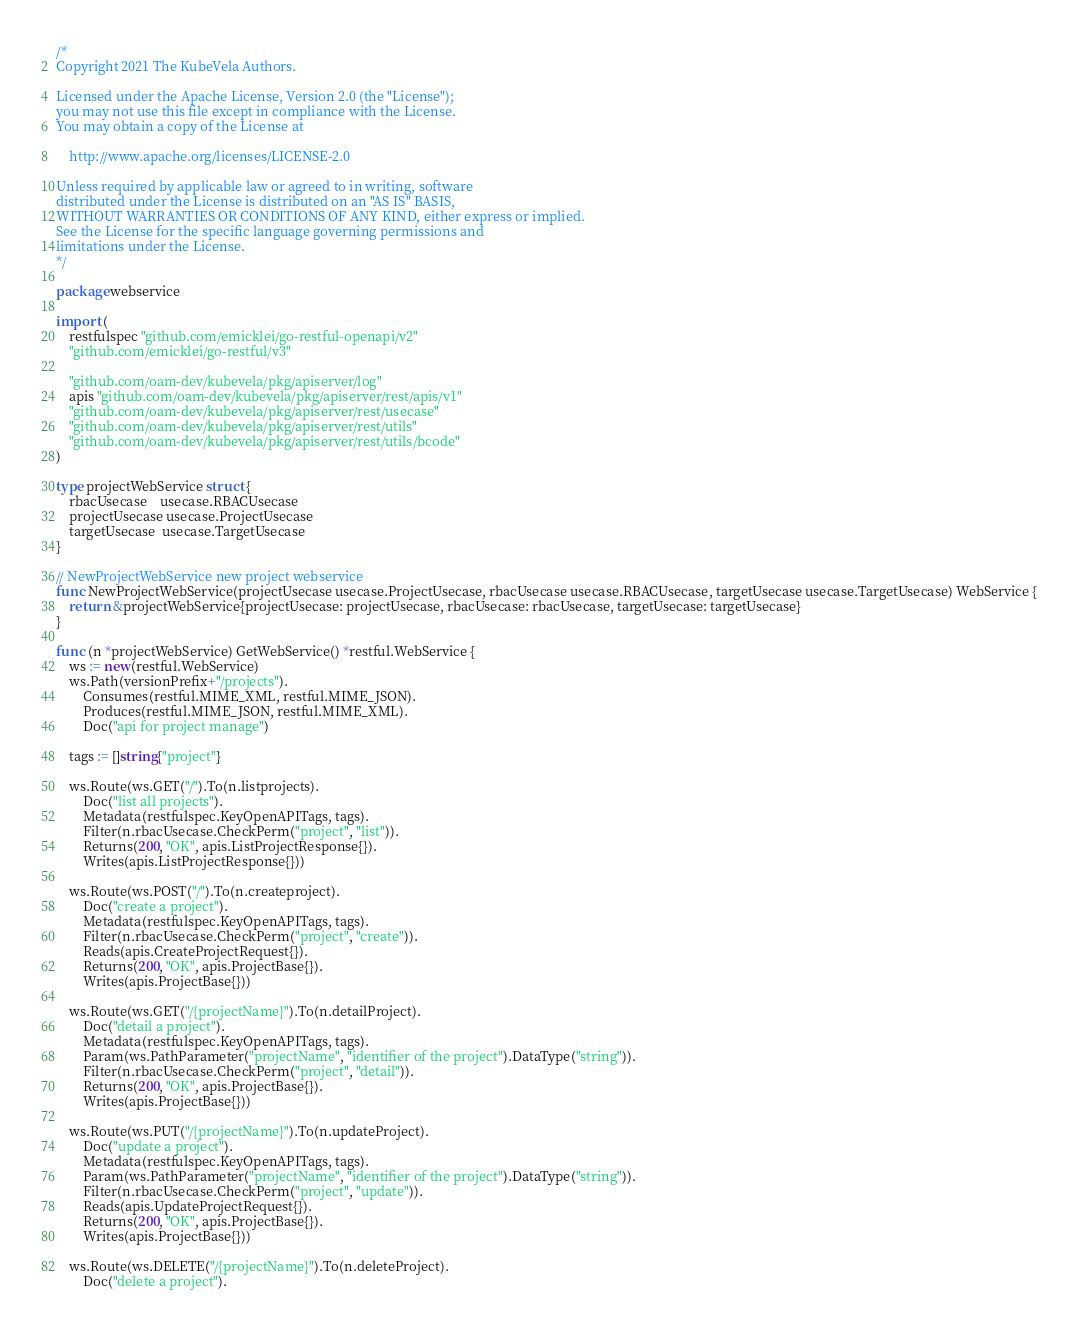<code> <loc_0><loc_0><loc_500><loc_500><_Go_>/*
Copyright 2021 The KubeVela Authors.

Licensed under the Apache License, Version 2.0 (the "License");
you may not use this file except in compliance with the License.
You may obtain a copy of the License at

	http://www.apache.org/licenses/LICENSE-2.0

Unless required by applicable law or agreed to in writing, software
distributed under the License is distributed on an "AS IS" BASIS,
WITHOUT WARRANTIES OR CONDITIONS OF ANY KIND, either express or implied.
See the License for the specific language governing permissions and
limitations under the License.
*/

package webservice

import (
	restfulspec "github.com/emicklei/go-restful-openapi/v2"
	"github.com/emicklei/go-restful/v3"

	"github.com/oam-dev/kubevela/pkg/apiserver/log"
	apis "github.com/oam-dev/kubevela/pkg/apiserver/rest/apis/v1"
	"github.com/oam-dev/kubevela/pkg/apiserver/rest/usecase"
	"github.com/oam-dev/kubevela/pkg/apiserver/rest/utils"
	"github.com/oam-dev/kubevela/pkg/apiserver/rest/utils/bcode"
)

type projectWebService struct {
	rbacUsecase    usecase.RBACUsecase
	projectUsecase usecase.ProjectUsecase
	targetUsecase  usecase.TargetUsecase
}

// NewProjectWebService new project webservice
func NewProjectWebService(projectUsecase usecase.ProjectUsecase, rbacUsecase usecase.RBACUsecase, targetUsecase usecase.TargetUsecase) WebService {
	return &projectWebService{projectUsecase: projectUsecase, rbacUsecase: rbacUsecase, targetUsecase: targetUsecase}
}

func (n *projectWebService) GetWebService() *restful.WebService {
	ws := new(restful.WebService)
	ws.Path(versionPrefix+"/projects").
		Consumes(restful.MIME_XML, restful.MIME_JSON).
		Produces(restful.MIME_JSON, restful.MIME_XML).
		Doc("api for project manage")

	tags := []string{"project"}

	ws.Route(ws.GET("/").To(n.listprojects).
		Doc("list all projects").
		Metadata(restfulspec.KeyOpenAPITags, tags).
		Filter(n.rbacUsecase.CheckPerm("project", "list")).
		Returns(200, "OK", apis.ListProjectResponse{}).
		Writes(apis.ListProjectResponse{}))

	ws.Route(ws.POST("/").To(n.createproject).
		Doc("create a project").
		Metadata(restfulspec.KeyOpenAPITags, tags).
		Filter(n.rbacUsecase.CheckPerm("project", "create")).
		Reads(apis.CreateProjectRequest{}).
		Returns(200, "OK", apis.ProjectBase{}).
		Writes(apis.ProjectBase{}))

	ws.Route(ws.GET("/{projectName}").To(n.detailProject).
		Doc("detail a project").
		Metadata(restfulspec.KeyOpenAPITags, tags).
		Param(ws.PathParameter("projectName", "identifier of the project").DataType("string")).
		Filter(n.rbacUsecase.CheckPerm("project", "detail")).
		Returns(200, "OK", apis.ProjectBase{}).
		Writes(apis.ProjectBase{}))

	ws.Route(ws.PUT("/{projectName}").To(n.updateProject).
		Doc("update a project").
		Metadata(restfulspec.KeyOpenAPITags, tags).
		Param(ws.PathParameter("projectName", "identifier of the project").DataType("string")).
		Filter(n.rbacUsecase.CheckPerm("project", "update")).
		Reads(apis.UpdateProjectRequest{}).
		Returns(200, "OK", apis.ProjectBase{}).
		Writes(apis.ProjectBase{}))

	ws.Route(ws.DELETE("/{projectName}").To(n.deleteProject).
		Doc("delete a project").</code> 